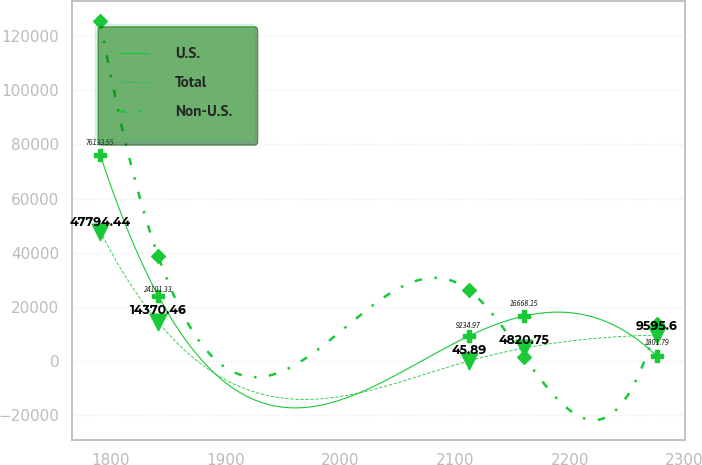Convert chart to OTSL. <chart><loc_0><loc_0><loc_500><loc_500><line_chart><ecel><fcel>U.S.<fcel>Total<fcel>Non-U.S.<nl><fcel>1790.81<fcel>76133.6<fcel>47794.4<fcel>125552<nl><fcel>1841.43<fcel>24101.3<fcel>14370.5<fcel>38660.8<nl><fcel>2112<fcel>9234.97<fcel>45.89<fcel>26247.7<nl><fcel>2160.53<fcel>16668.2<fcel>4820.75<fcel>1421.55<nl><fcel>2276.13<fcel>1801.79<fcel>9595.6<fcel>13834.6<nl></chart> 